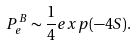Convert formula to latex. <formula><loc_0><loc_0><loc_500><loc_500>P ^ { B } _ { e } \sim \frac { 1 } { 4 } e x p ( - 4 S ) .</formula> 